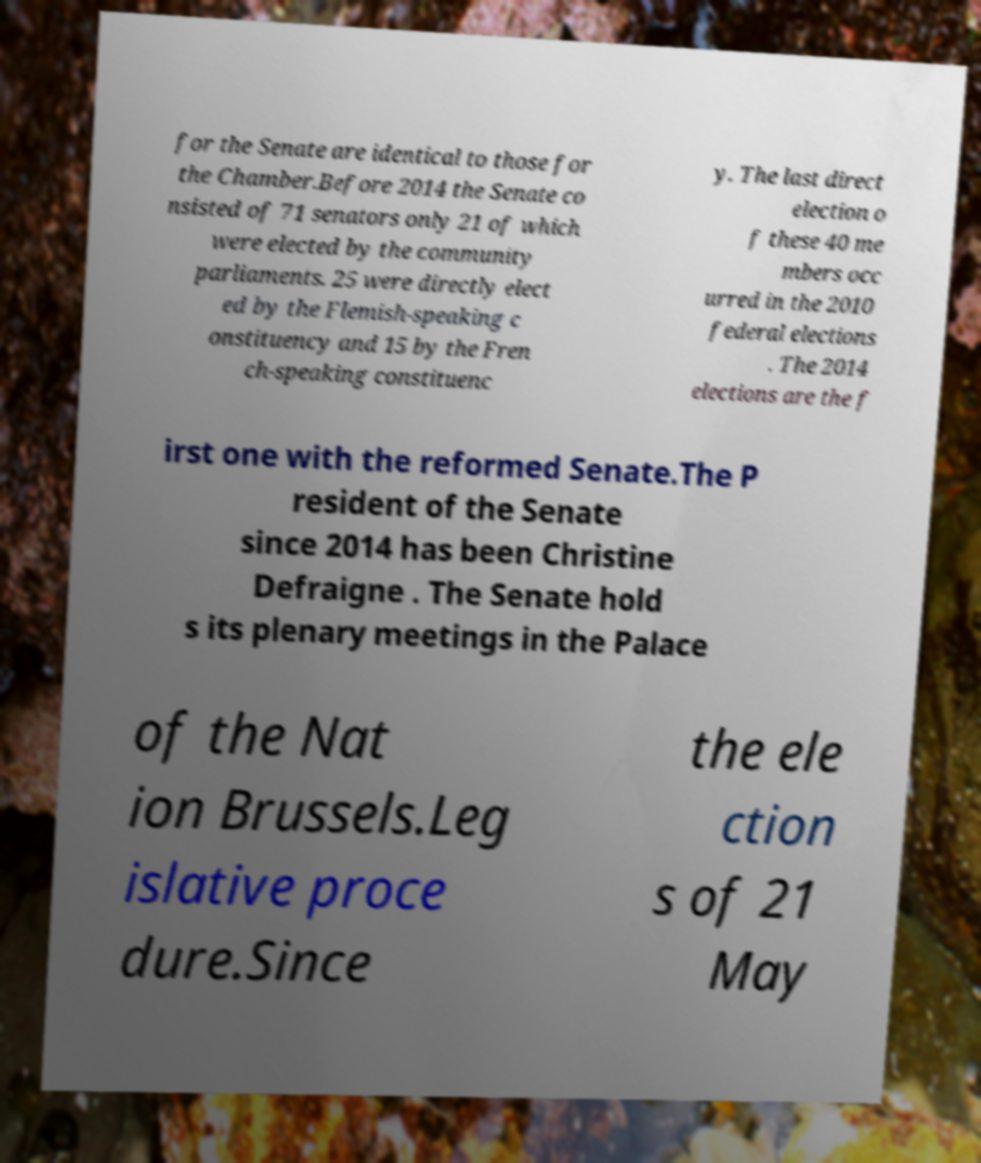Please read and relay the text visible in this image. What does it say? for the Senate are identical to those for the Chamber.Before 2014 the Senate co nsisted of 71 senators only 21 of which were elected by the community parliaments. 25 were directly elect ed by the Flemish-speaking c onstituency and 15 by the Fren ch-speaking constituenc y. The last direct election o f these 40 me mbers occ urred in the 2010 federal elections . The 2014 elections are the f irst one with the reformed Senate.The P resident of the Senate since 2014 has been Christine Defraigne . The Senate hold s its plenary meetings in the Palace of the Nat ion Brussels.Leg islative proce dure.Since the ele ction s of 21 May 